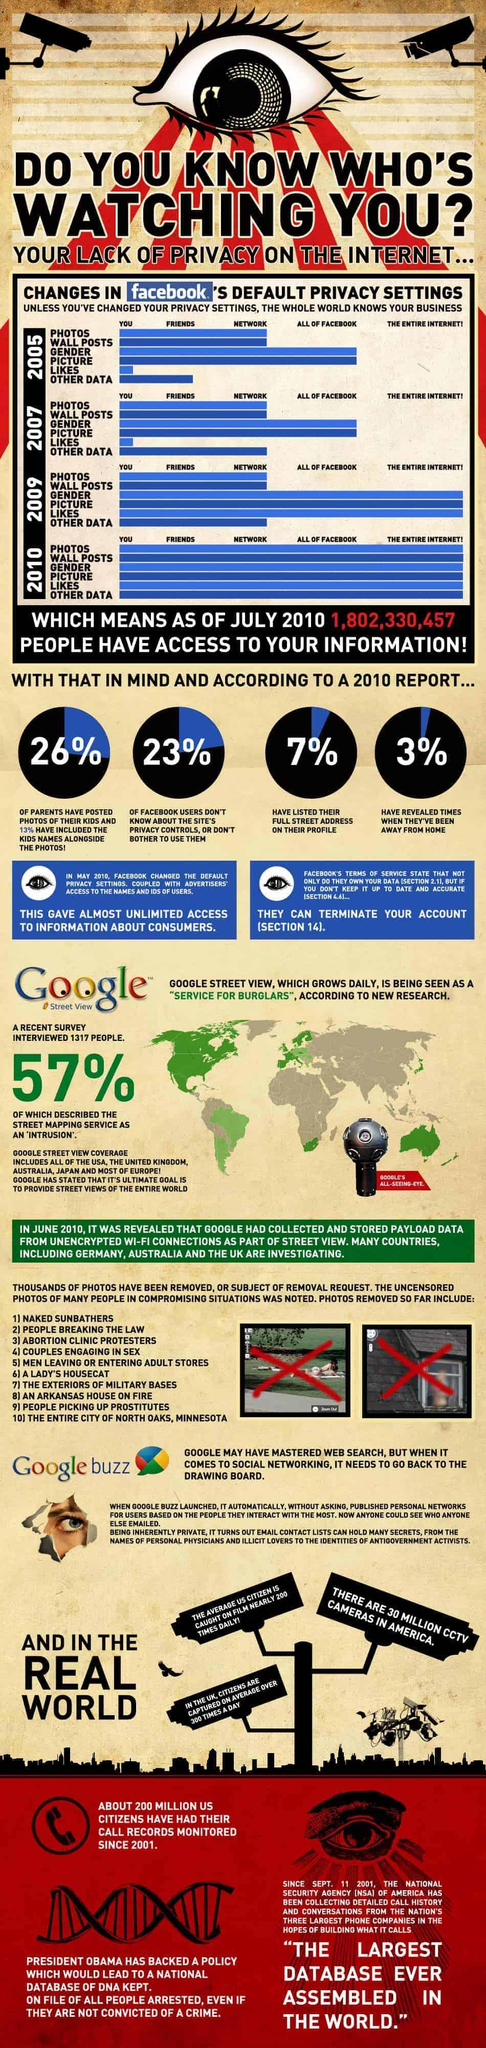What is the third in the list of photos that are removed from google data collection?
Answer the question with a short phrase. abortion clinic protesters What are the three kinds of data that are accessible to the entire internet according to 2009 and 2010 Facebook policy? gender, picture, likes according to 2009 policy, what are the three kind of data from Facebook that are accessible to everyone? gender, picture, likes according to 2010 report, what is the percentage of Facebook users who does not list their complete address on their profile? 93% According to Facebook policy of 2007 who can view the gender information of the user? all of the facebook In 2007 policy of Facebook, privacy of which data has changed from previous policy? other data What percentage of street mapping service are not described as intrusion? 43% what percent of parents posted photos of their children without name? 13% according to 2009 policy, what are the three kind of data from Facebook that are accessible to the entire network? photos, wall posts, other data according to 2005 policy, what are the two kind of data from Facebook that are accessible to all of the Facebook? gender, picture In which year Facebook made it's users gender data accessible for the whole internet? 2009 In which year Facebook made it's users whole data accessible for the entire internet? 2010 In 2005 Facebook policy, what is the only thing that is private to the user? likes 